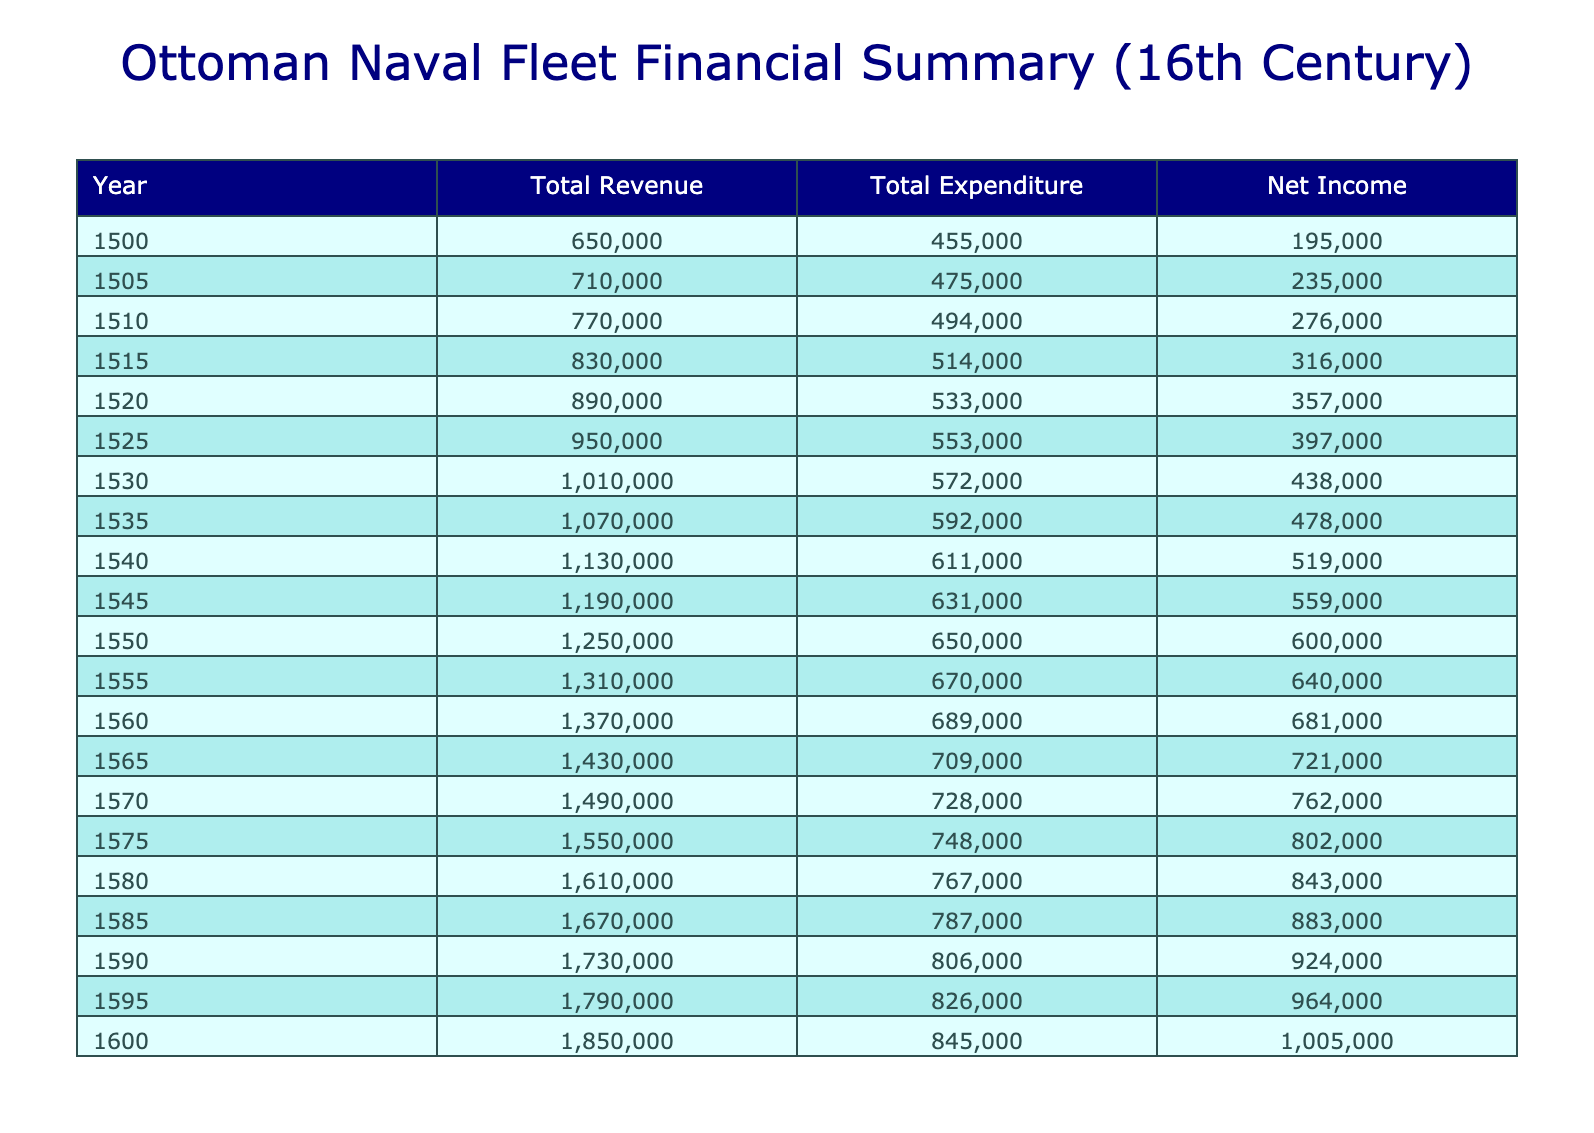What was the total revenue in 1550? The total revenue for 1550 can be found in the "Total Revenue" column. By looking at the row for the year 1550, the value is 1,250,000 Akces, which is the sum of revenue from trade routes, taxes, and conquests.
Answer: 1250000 Akces What was the total expenditure in 1520? The total expenditure for 1520 can be found in the "Total Expenditure" column. For the year 1520, the total expenditure is 1,030,000 Akces, which is calculated by adding the costs of ships, salaries, shipbuilding, naval expeditions, and miscellaneous costs for that year.
Answer: 1030000 Akces What was the net income in 1575? The net income for 1575 is calculated by finding the difference between total revenue and total expenditure for that year. The total revenue is 1,325,000 Akces and the total expenditure is 1,125,000 Akces, thus the net income is 200,000 Akces.
Answer: 200000 Akces Is the total revenue in 1600 greater than in 1500? To answer this, we compare the total revenue of the two years. The total revenue in 1600 is 1,500,000 Akces and in 1500, it is 950,000 Akces. Since 1,500,000 is greater than 950,000, the statement is true.
Answer: Yes What was the average total revenue for the years 1540 to 1560? To find the average total revenue for the years 1540 to 1560, we first sum the total revenues for those years. The total revenues are 1,390,000 (1540) + 1,430,000 (1545) + 1,470,000 (1550) + 1,510,000 (1555) + 1,550,000 (1560), which equals 7,350,000 Akces. We then divide by the number of years, which is 5: 7,350,000 / 5 = 1,470,000 Akces.
Answer: 1470000 Akces What was the change in net income from 1550 to 1560? To find the change in net income from 1550 to 1560, we first locate the net income for both years. In 1550, the net income is 100,000 Akces, and in 1560, it is 120,000 Akces. The change is calculated as 120,000 - 100,000 = 20,000 Akces, indicating an increase in net income.
Answer: 20000 Akces Was there a year in which total revenue equaled total expenditure? By examining the values in both columns across all years, we find that there is no year where total revenue matches total expenditure. In each recorded year, total revenue always exceeds expenditure.
Answer: No How much did the maintenance costs increase from 1500 to 1585? To determine the increase in maintenance costs, we find the maintenance costs for both years. In 1500, the costs are 100,000 Akces, and in 1585, they are 185,000 Akces. The increase is 185,000 - 100,000 = 85,000 Akces.
Answer: 85000 Akces 